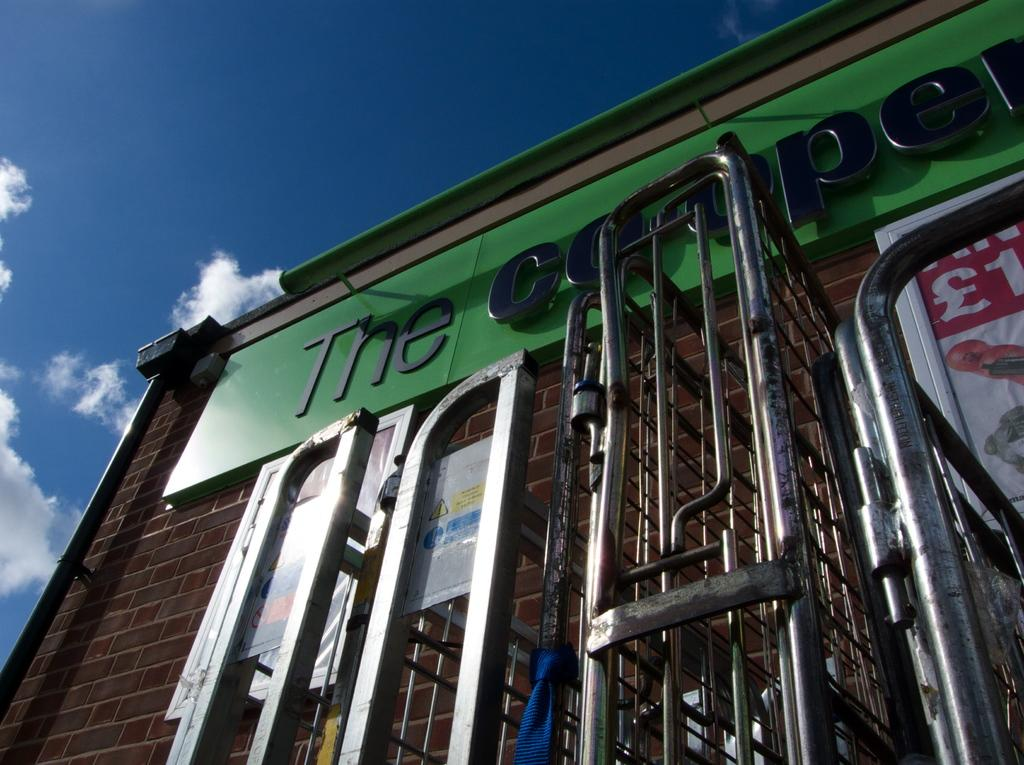<image>
Describe the image concisely. a building that says 'the' on the side of it at the top 